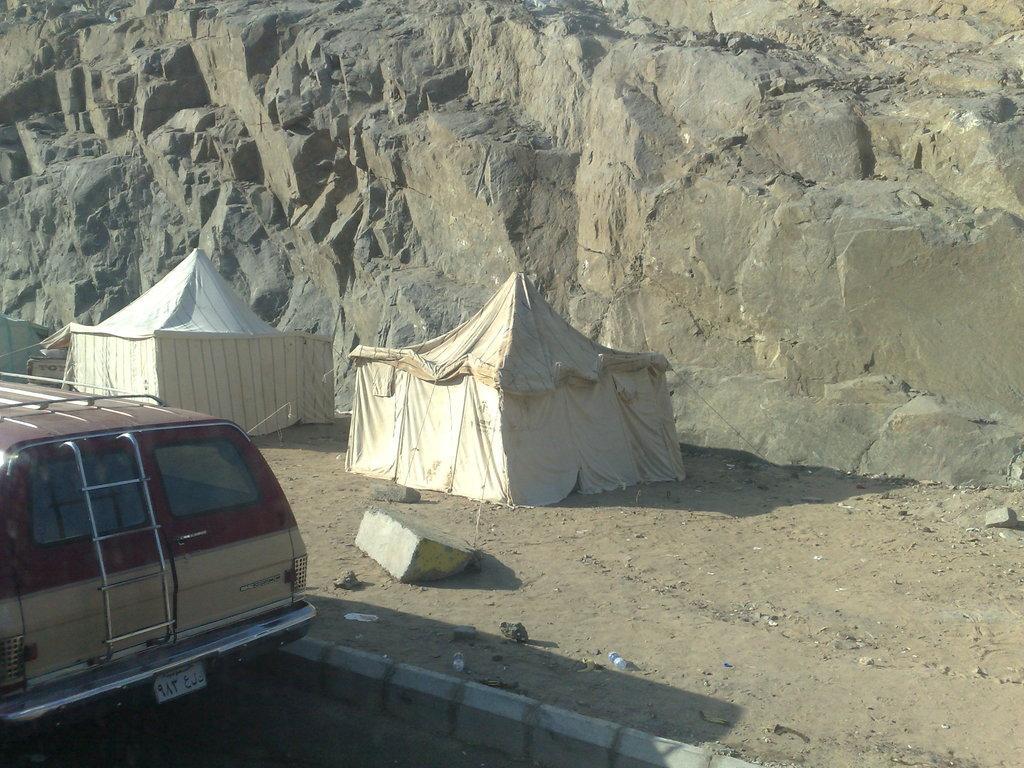Can you describe this image briefly? In the picture I can see two white color tent houses and there is a vehicle beside it in the left corner and there is a rock mountain in the background. 